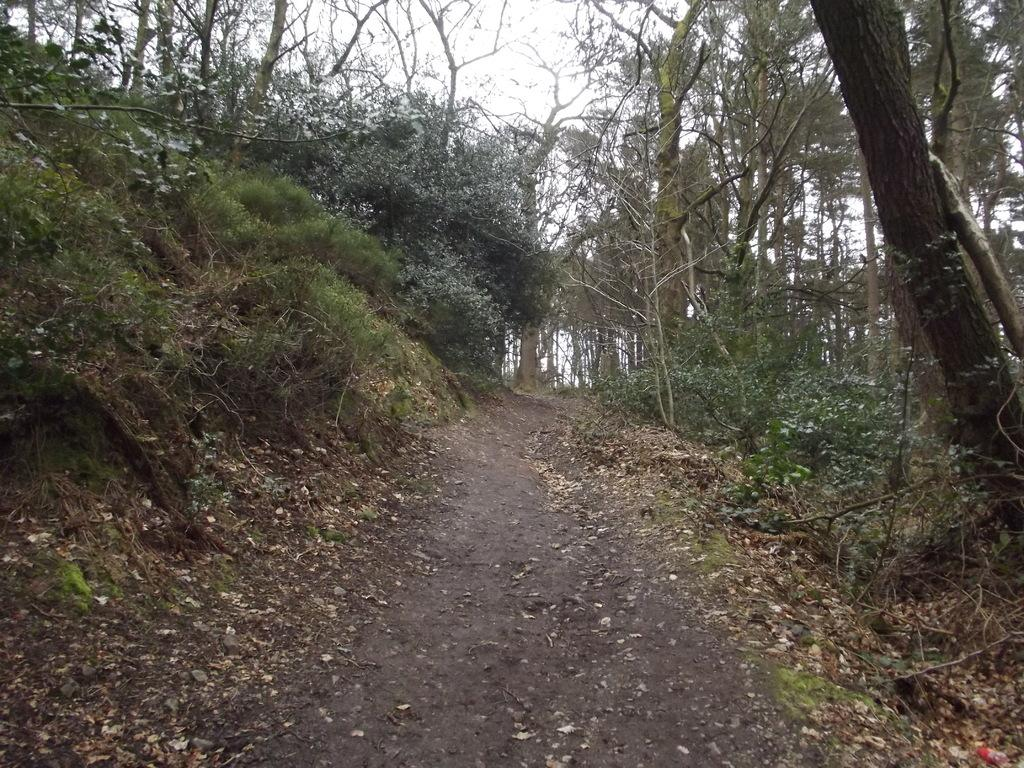What type of vegetation can be seen in the image? There are trees in the image. What else can be seen in the image besides trees? There is a road in the image. What is visible in the background of the image? The sky is visible in the background of the image. Can you tell me how many horses are grazing on the grass in the image? There are no horses or grass present in the image; it features trees and a road. What type of judge is depicted in the image? There is no judge present in the image. 